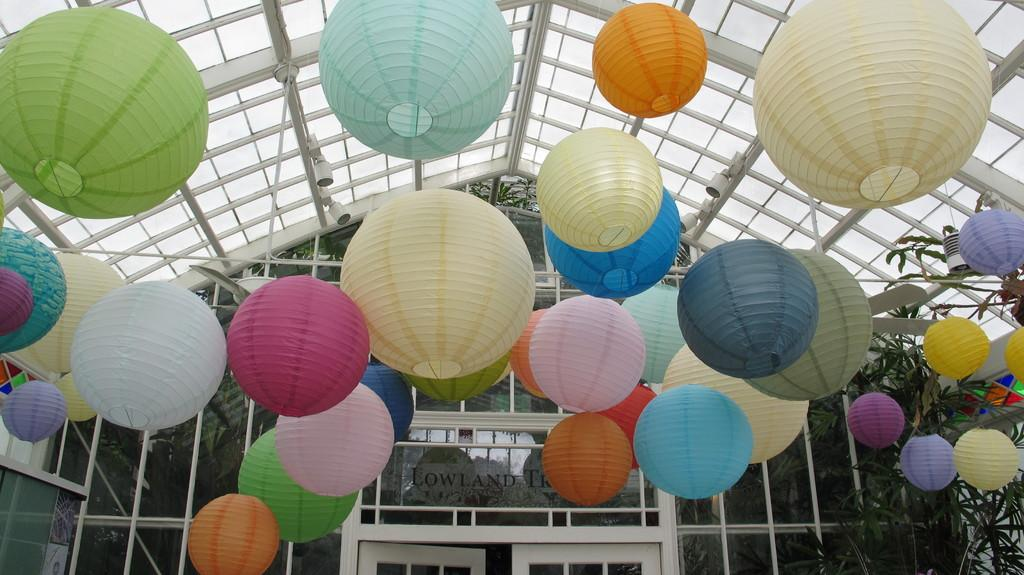What type of objects are present in the image? There are light balls in the image. What other elements can be seen in the image? There are plants and a house fence in the image. Is there any text present in the image? Yes, there is some text in the image. How many sisters are depicted in the image? There are no people, let alone sisters, present in the image. 